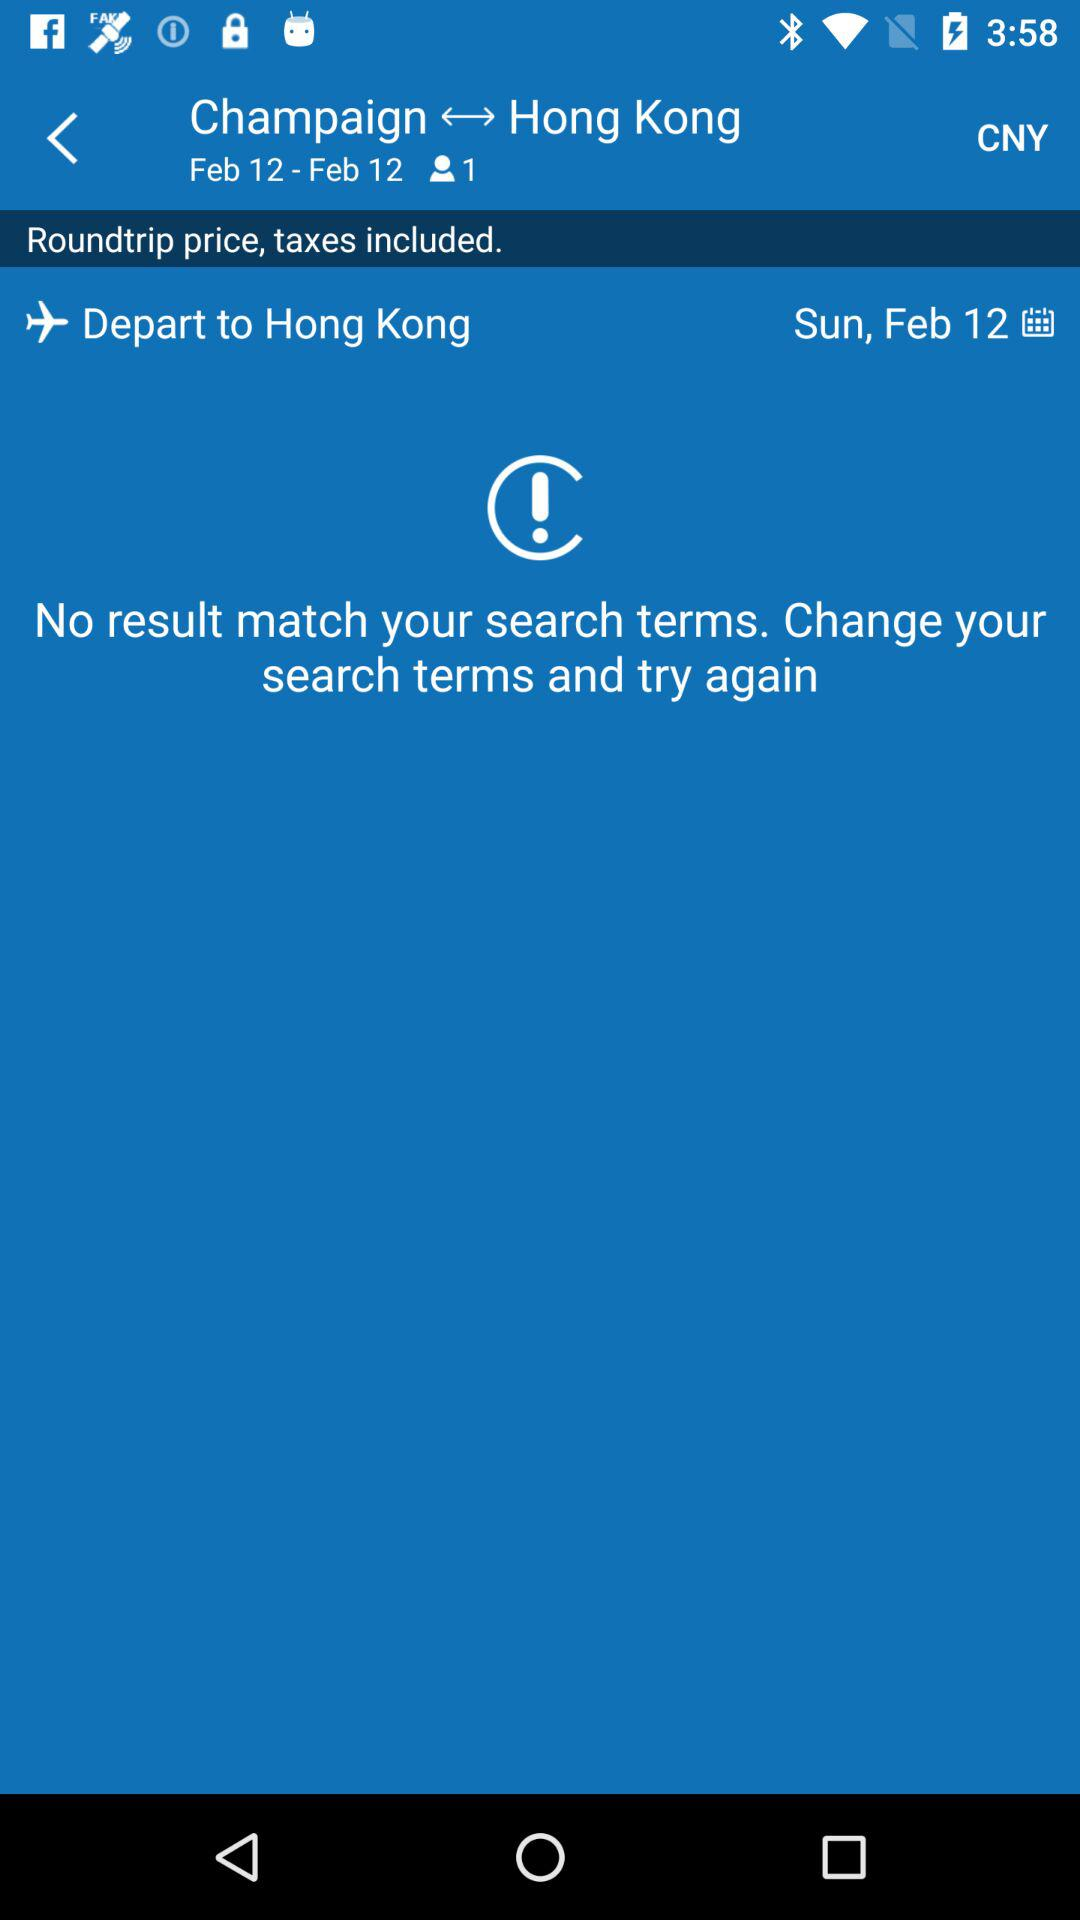For how many passengers is the flight booked? The flight is booked for one passenger. 